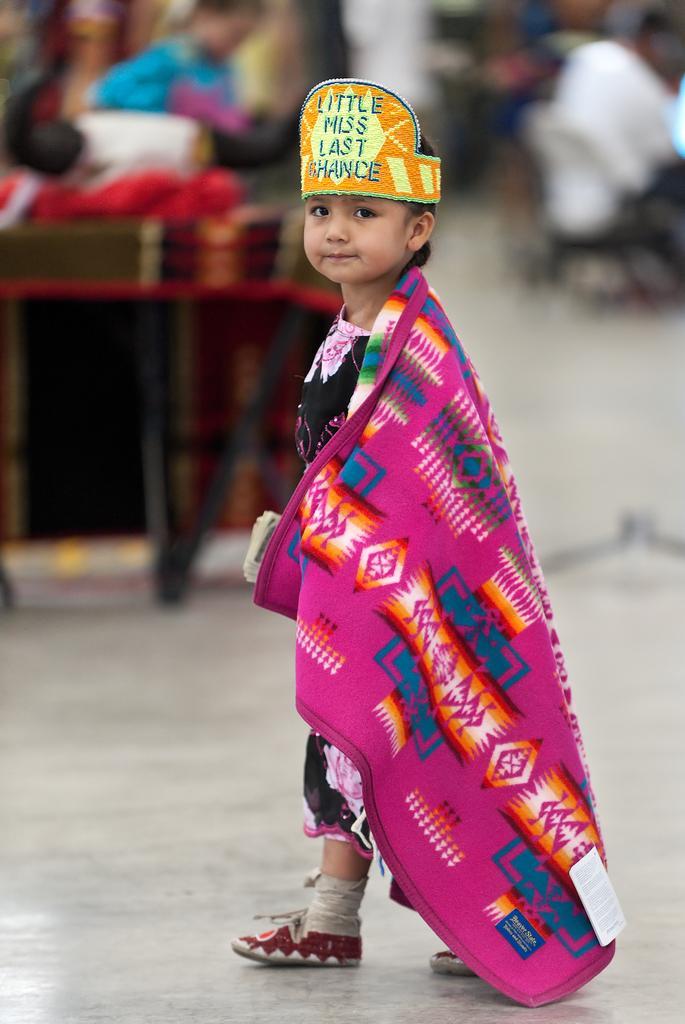Describe this image in one or two sentences. In this image we can see a boy wearing a crown. In the background of the image there are people. At the bottom of the image there is floor. 